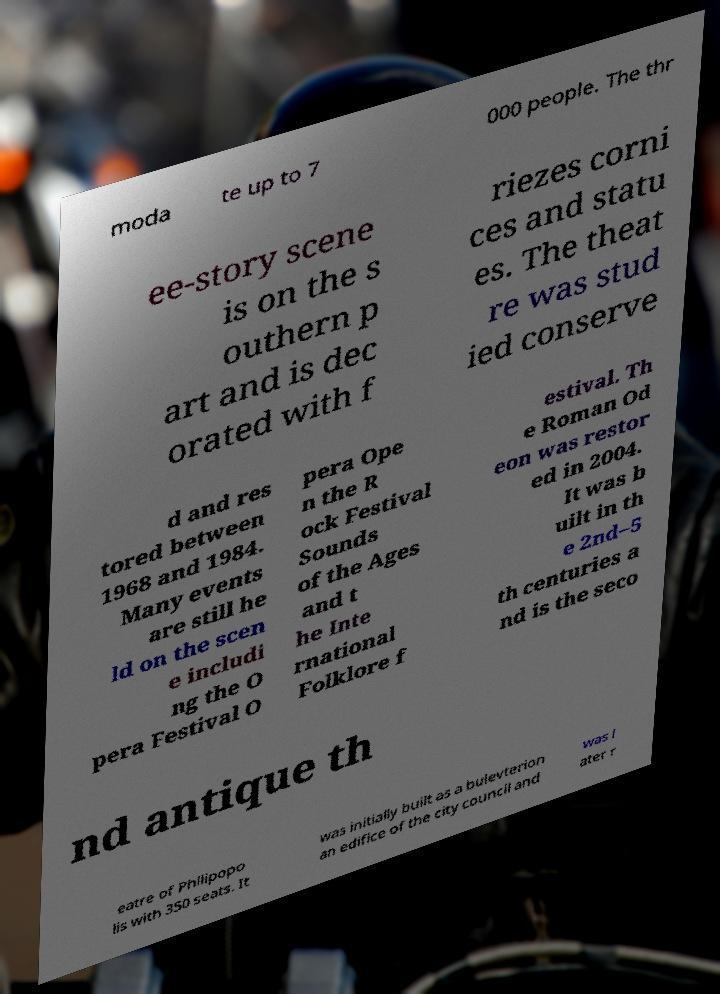Could you extract and type out the text from this image? moda te up to 7 000 people. The thr ee-story scene is on the s outhern p art and is dec orated with f riezes corni ces and statu es. The theat re was stud ied conserve d and res tored between 1968 and 1984. Many events are still he ld on the scen e includi ng the O pera Festival O pera Ope n the R ock Festival Sounds of the Ages and t he Inte rnational Folklore f estival. Th e Roman Od eon was restor ed in 2004. It was b uilt in th e 2nd–5 th centuries a nd is the seco nd antique th eatre of Philipopo lis with 350 seats. It was initially built as a bulevterion an edifice of the city council and was l ater r 